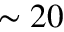<formula> <loc_0><loc_0><loc_500><loc_500>\sim 2 0</formula> 